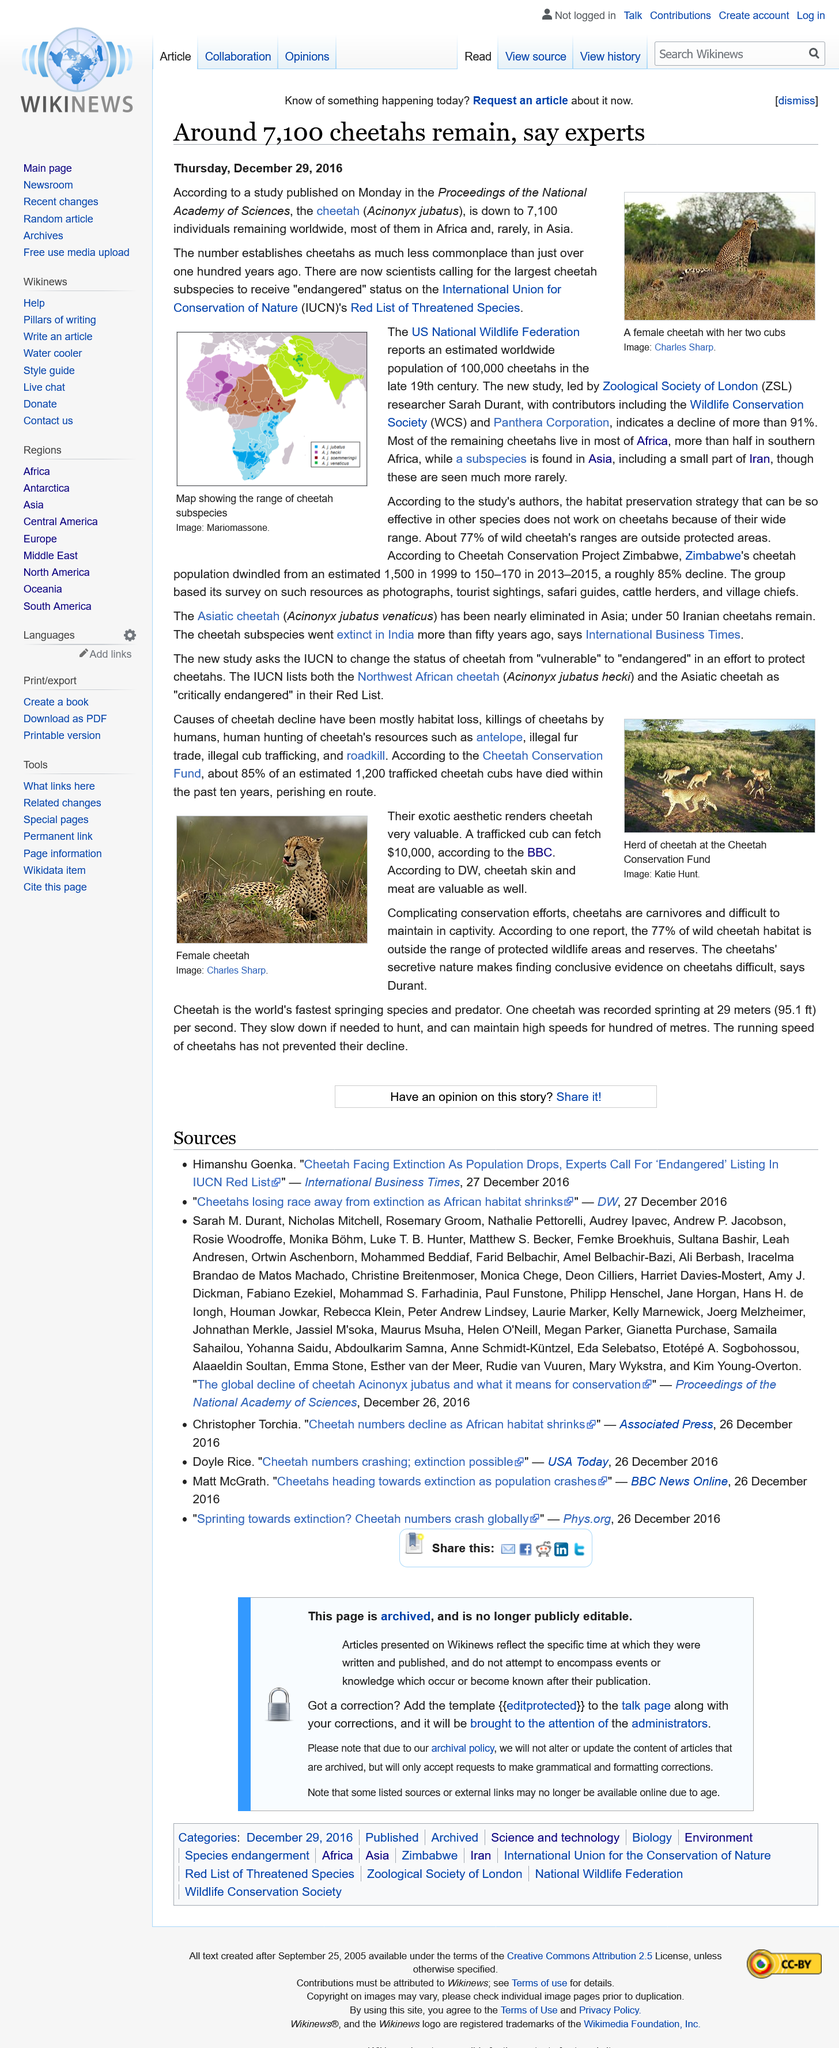Highlight a few significant elements in this photo. International Union for Conservation of Nature" is the full name of IUCN, which is an organization dedicated to conserving and protecting biodiversity around the world. The majority of cheetahs can be found in Africa, where they continue to thrive in the wild. The photograph of a female cheetah was taken by Charles Sharp. The estimated population of cheetahs in the late 19th century was approximately 100,000 individuals. The main causes of cheetah decline are habitat loss, human killings of cheetahs, and the hunting of cheetah resources by humans. 